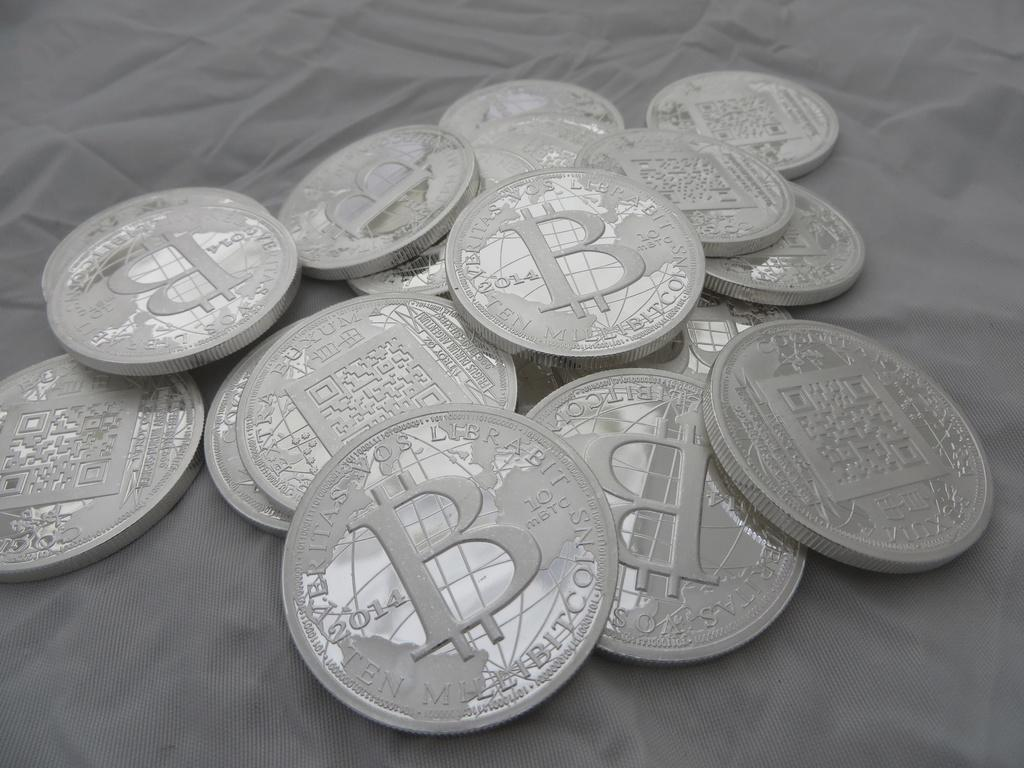<image>
Relay a brief, clear account of the picture shown. A pile of coins reveals that they each have the letter B on them. 